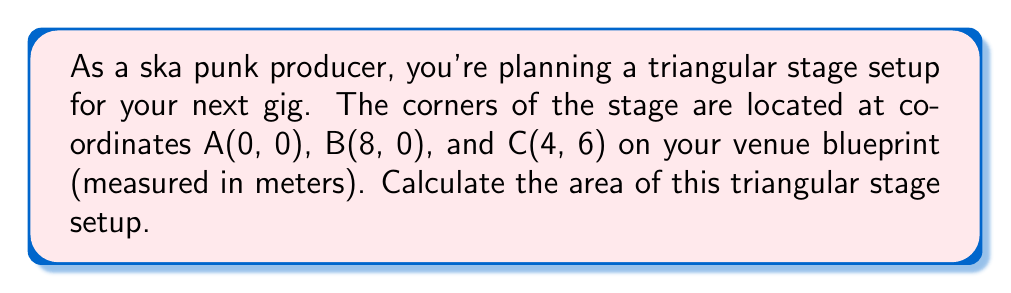Can you answer this question? To calculate the area of a triangular stage setup using the coordinates of its corners, we can use the formula for the area of a triangle given the coordinates of its vertices:

$$\text{Area} = \frac{1}{2}|x_1(y_2 - y_3) + x_2(y_3 - y_1) + x_3(y_1 - y_2)|$$

Where $(x_1, y_1)$, $(x_2, y_2)$, and $(x_3, y_3)$ are the coordinates of the three vertices.

Given:
- A(0, 0): $(x_1, y_1) = (0, 0)$
- B(8, 0): $(x_2, y_2) = (8, 0)$
- C(4, 6): $(x_3, y_3) = (4, 6)$

Let's substitute these values into the formula:

$$\begin{align*}
\text{Area} &= \frac{1}{2}|0(0 - 6) + 8(6 - 0) + 4(0 - 0)| \\
&= \frac{1}{2}|0 + 48 + 0| \\
&= \frac{1}{2}(48) \\
&= 24
\end{align*}$$

Therefore, the area of the triangular stage setup is 24 square meters.

[asy]
unitsize(1cm);
draw((0,0)--(8,0)--(4,6)--cycle);
label("A(0,0)", (0,0), SW);
label("B(8,0)", (8,0), SE);
label("C(4,6)", (4,6), N);
label("8m", (4,0), S);
label("6m", (4,3), E);
[/asy]
Answer: 24 m² 